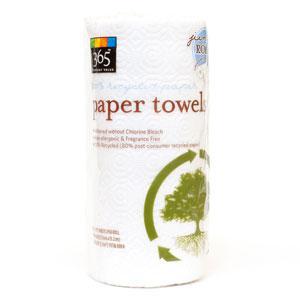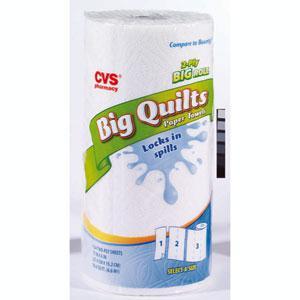The first image is the image on the left, the second image is the image on the right. Evaluate the accuracy of this statement regarding the images: "Two individually wrapped rolls of paper towels are both standing upright and have similar brand labels, but are shown with different background colors.". Is it true? Answer yes or no. No. The first image is the image on the left, the second image is the image on the right. For the images shown, is this caption "Each image shows an individually-wrapped single roll of paper towels, and left and right packages have the same sunburst logo on front." true? Answer yes or no. No. 